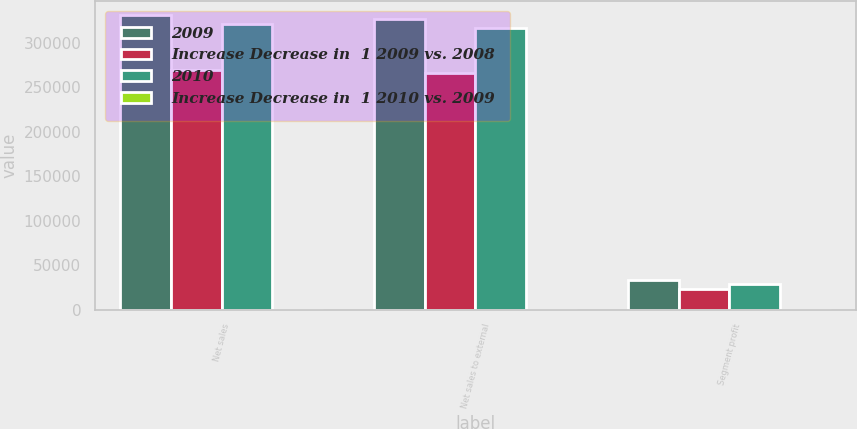Convert chart to OTSL. <chart><loc_0><loc_0><loc_500><loc_500><stacked_bar_chart><ecel><fcel>Net sales<fcel>Net sales to external<fcel>Segment profit<nl><fcel>2009<fcel>330759<fcel>326421<fcel>32795<nl><fcel>Increase Decrease in  1 2009 vs. 2008<fcel>269926<fcel>265952<fcel>23522<nl><fcel>2010<fcel>321480<fcel>316203<fcel>28691<nl><fcel>Increase Decrease in  1 2010 vs. 2009<fcel>23<fcel>23<fcel>39<nl></chart> 